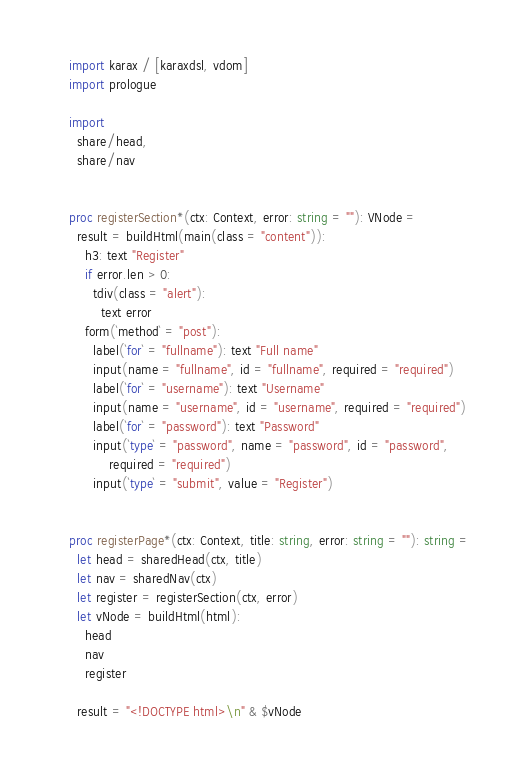<code> <loc_0><loc_0><loc_500><loc_500><_Nim_>import karax / [karaxdsl, vdom]
import prologue

import
  share/head,
  share/nav


proc registerSection*(ctx: Context, error: string = ""): VNode =
  result = buildHtml(main(class = "content")):
    h3: text "Register"
    if error.len > 0:
      tdiv(class = "alert"):
        text error
    form(`method` = "post"):
      label(`for` = "fullname"): text "Full name"
      input(name = "fullname", id = "fullname", required = "required")
      label(`for` = "username"): text "Username"
      input(name = "username", id = "username", required = "required")
      label(`for` = "password"): text "Password"
      input(`type` = "password", name = "password", id = "password",
          required = "required")
      input(`type` = "submit", value = "Register")


proc registerPage*(ctx: Context, title: string, error: string = ""): string =
  let head = sharedHead(ctx, title)
  let nav = sharedNav(ctx)
  let register = registerSection(ctx, error)
  let vNode = buildHtml(html):
    head
    nav
    register

  result = "<!DOCTYPE html>\n" & $vNode
</code> 